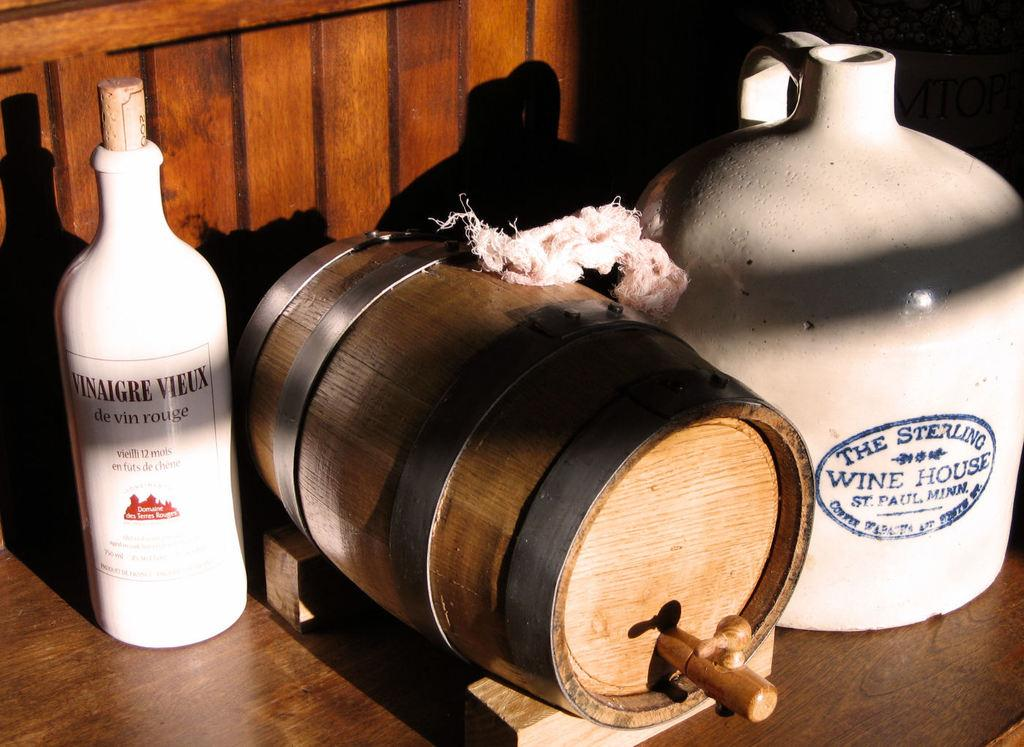What type of container is present in the image? There is a bottle and a jar in the image. What other object can be seen in the image? There is a barrel in the image. What material is covering the objects? There is a cloth in the image. On what surface are the objects placed? The objects are on a wooden platform. What type of appliance is being used to cook the beef in the image? There is no appliance or beef present in the image. 